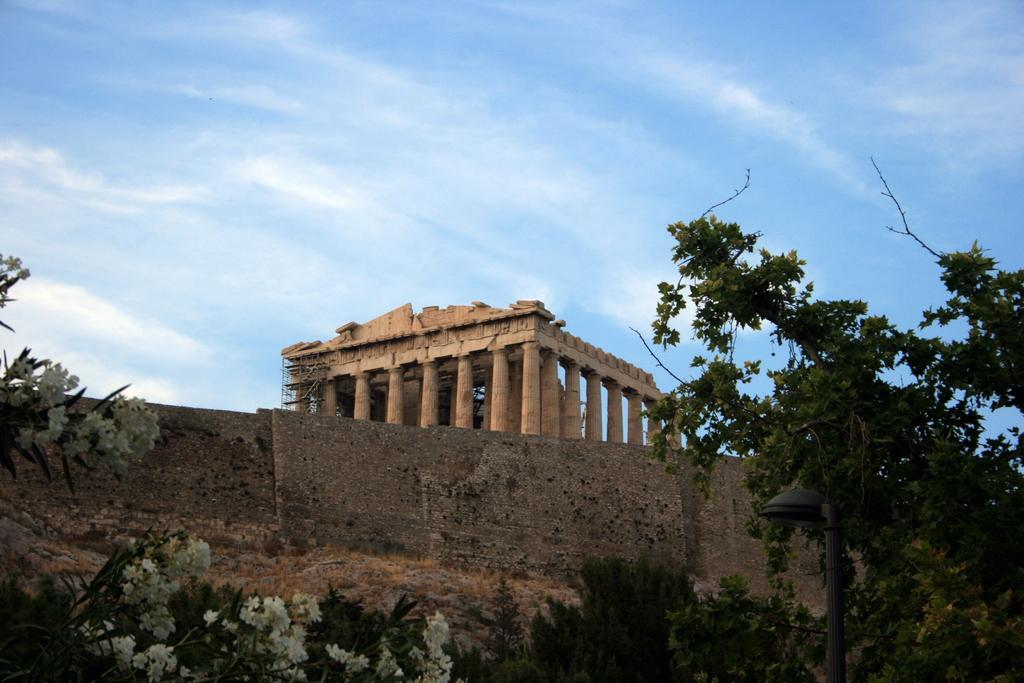Please provide a concise description of this image. In this image we can see the wall, in front of the wall we can see the trees and flowers. In the background, we can see the pillars and the sky. 